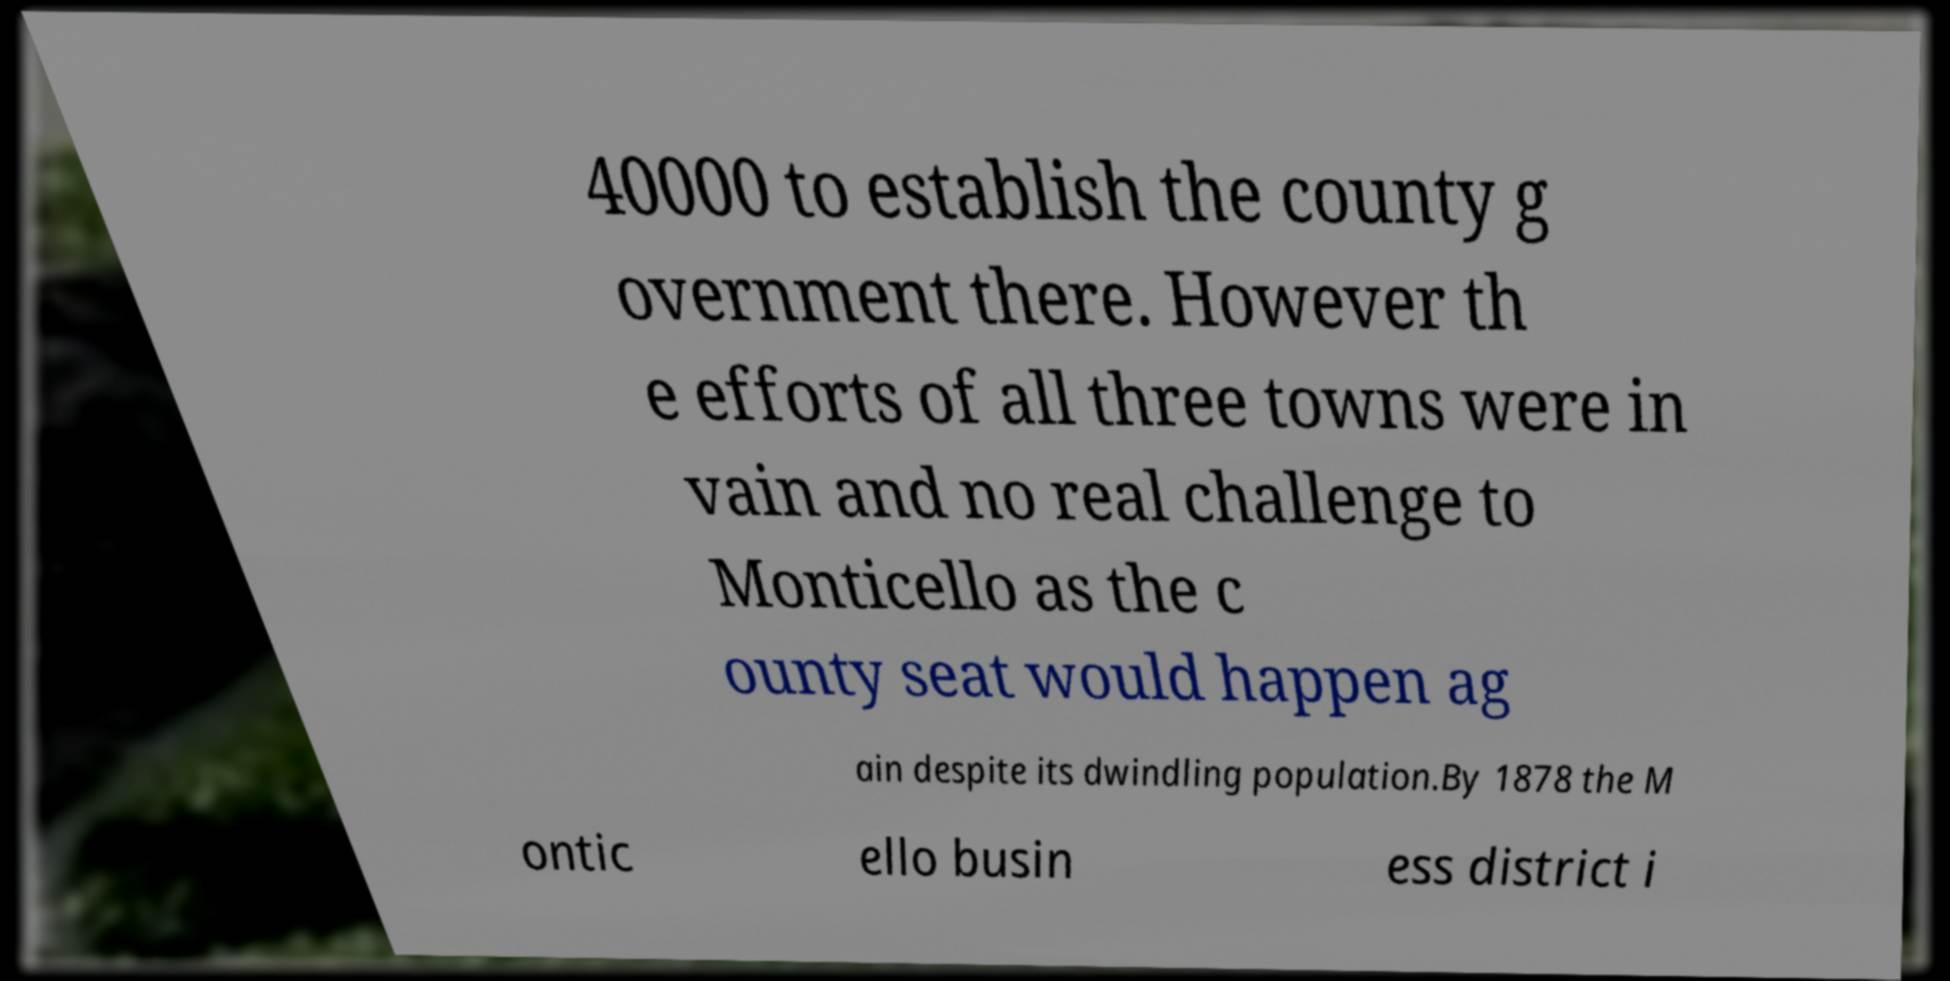Can you accurately transcribe the text from the provided image for me? 40000 to establish the county g overnment there. However th e efforts of all three towns were in vain and no real challenge to Monticello as the c ounty seat would happen ag ain despite its dwindling population.By 1878 the M ontic ello busin ess district i 